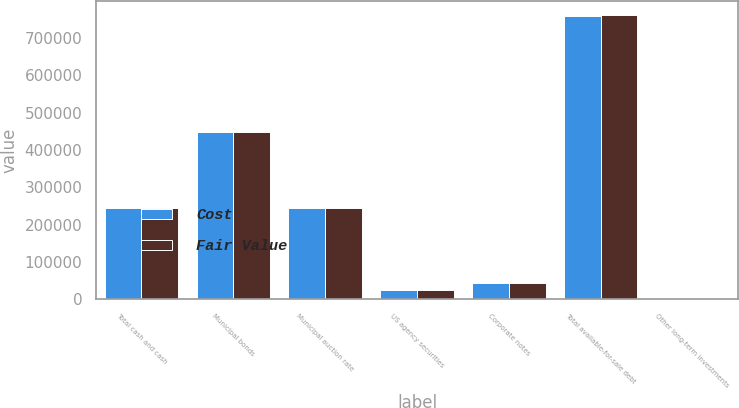<chart> <loc_0><loc_0><loc_500><loc_500><stacked_bar_chart><ecel><fcel>Total cash and cash<fcel>Municipal bonds<fcel>Municipal auction rate<fcel>US agency securities<fcel>Corporate notes<fcel>Total available-for-sale debt<fcel>Other long-term investments<nl><fcel>Cost<fcel>244525<fcel>446875<fcel>244525<fcel>24680<fcel>43675<fcel>759755<fcel>3445<nl><fcel>Fair Value<fcel>244525<fcel>448273<fcel>244525<fcel>24712<fcel>44258<fcel>761768<fcel>3445<nl></chart> 